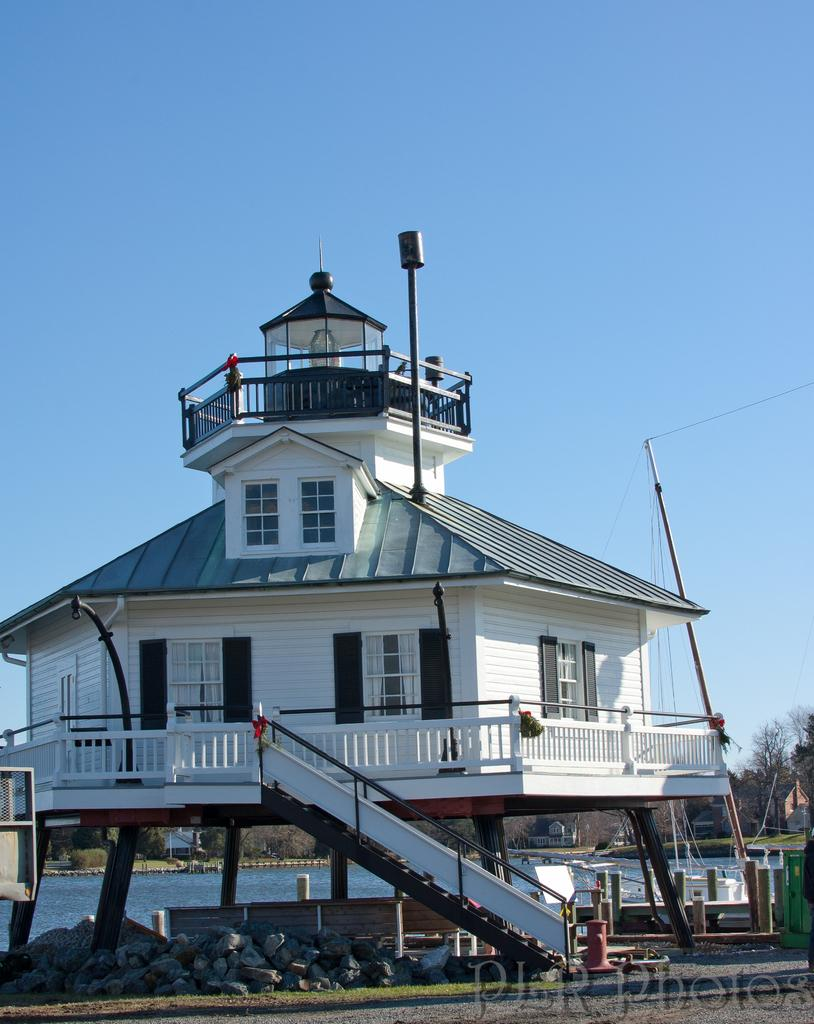What is the main subject in the center of the image? There is a house in the center of the image. What type of objects can be seen on the ground in the image? There are stones visible in the image. What natural element is present in the image? There is water visible in the image. What can be seen in the distance in the image? There are trees in the background of the image. How many apples are on the card that someone is coughing up in the image? There are no apples, cards, or coughing individuals present in the image. 